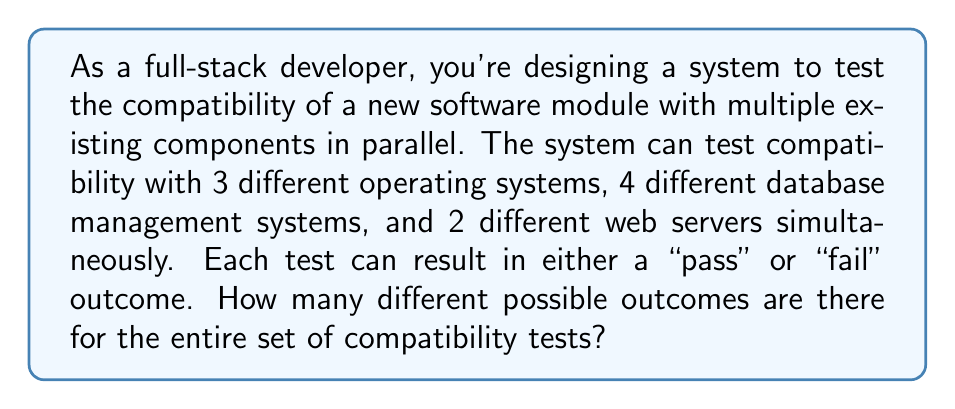Solve this math problem. Let's approach this step-by-step:

1) We have three separate conditions being tested in parallel:
   - Operating Systems (OS): 3 options
   - Database Management Systems (DBMS): 4 options
   - Web Servers: 2 options

2) For each of these tests, we have two possible outcomes: "pass" or "fail"

3) This scenario is a perfect application of the Multiplication Principle in combinatorics. When we have independent events occurring simultaneously, we multiply the number of possible outcomes for each event.

4) For each individual test:
   - OS: 2 outcomes (pass/fail) for each of the 3 systems: $2^3 = 8$ possibilities
   - DBMS: 2 outcomes for each of the 4 systems: $2^4 = 16$ possibilities
   - Web Servers: 2 outcomes for each of the 2 servers: $2^2 = 4$ possibilities

5) Now, to find the total number of possible outcomes for all tests combined, we multiply these individual results:

   $$ \text{Total Outcomes} = 2^3 \times 2^4 \times 2^2 $$

6) We can simplify this:

   $$ \text{Total Outcomes} = 2^{3+4+2} = 2^9 = 512 $$

Therefore, there are 512 different possible outcomes for the entire set of compatibility tests.
Answer: 512 possible outcomes 